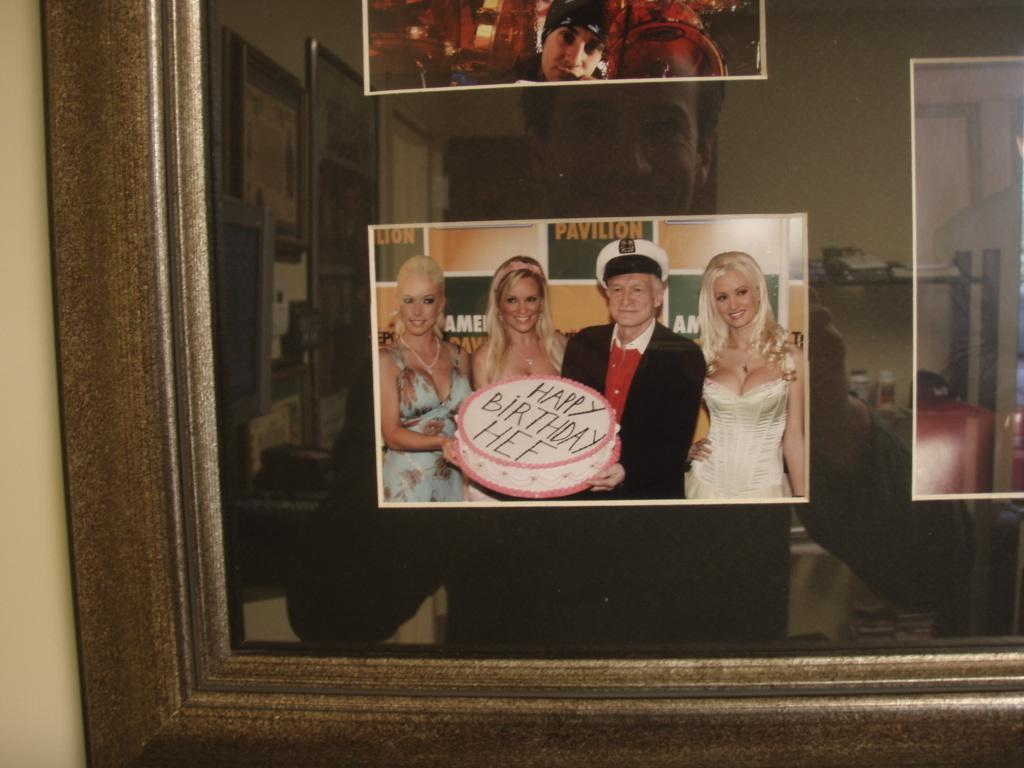What is attached to the wall in the image? There is a frame attached to the wall in the image. What is inside the frame? The frame contains three photographs of persons. Can you describe the reflection on the frame's glass? There is a reflection of a person on the frame's glass. How many trains are visible in the image? There are no trains present in the image. What type of letters can be seen on the photographs in the frame? There is no mention of letters on the photographs in the frame; the photographs depict persons. 